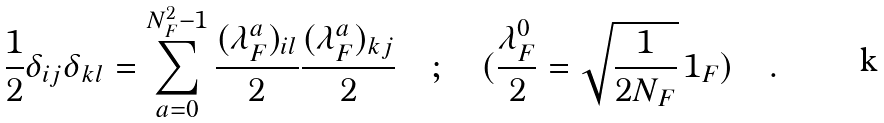<formula> <loc_0><loc_0><loc_500><loc_500>\frac { 1 } { 2 } \delta _ { i j } \delta _ { k l } = \sum _ { a = 0 } ^ { N _ { F } ^ { 2 } - 1 } \frac { ( \lambda ^ { a } _ { F } ) _ { i l } } { 2 } \frac { ( \lambda ^ { a } _ { F } ) _ { k j } } { 2 } \quad ; \quad ( \frac { \lambda ^ { 0 } _ { F } } { 2 } = \sqrt { \frac { 1 } { 2 N _ { F } } } { \, 1 } _ { F } ) \quad .</formula> 